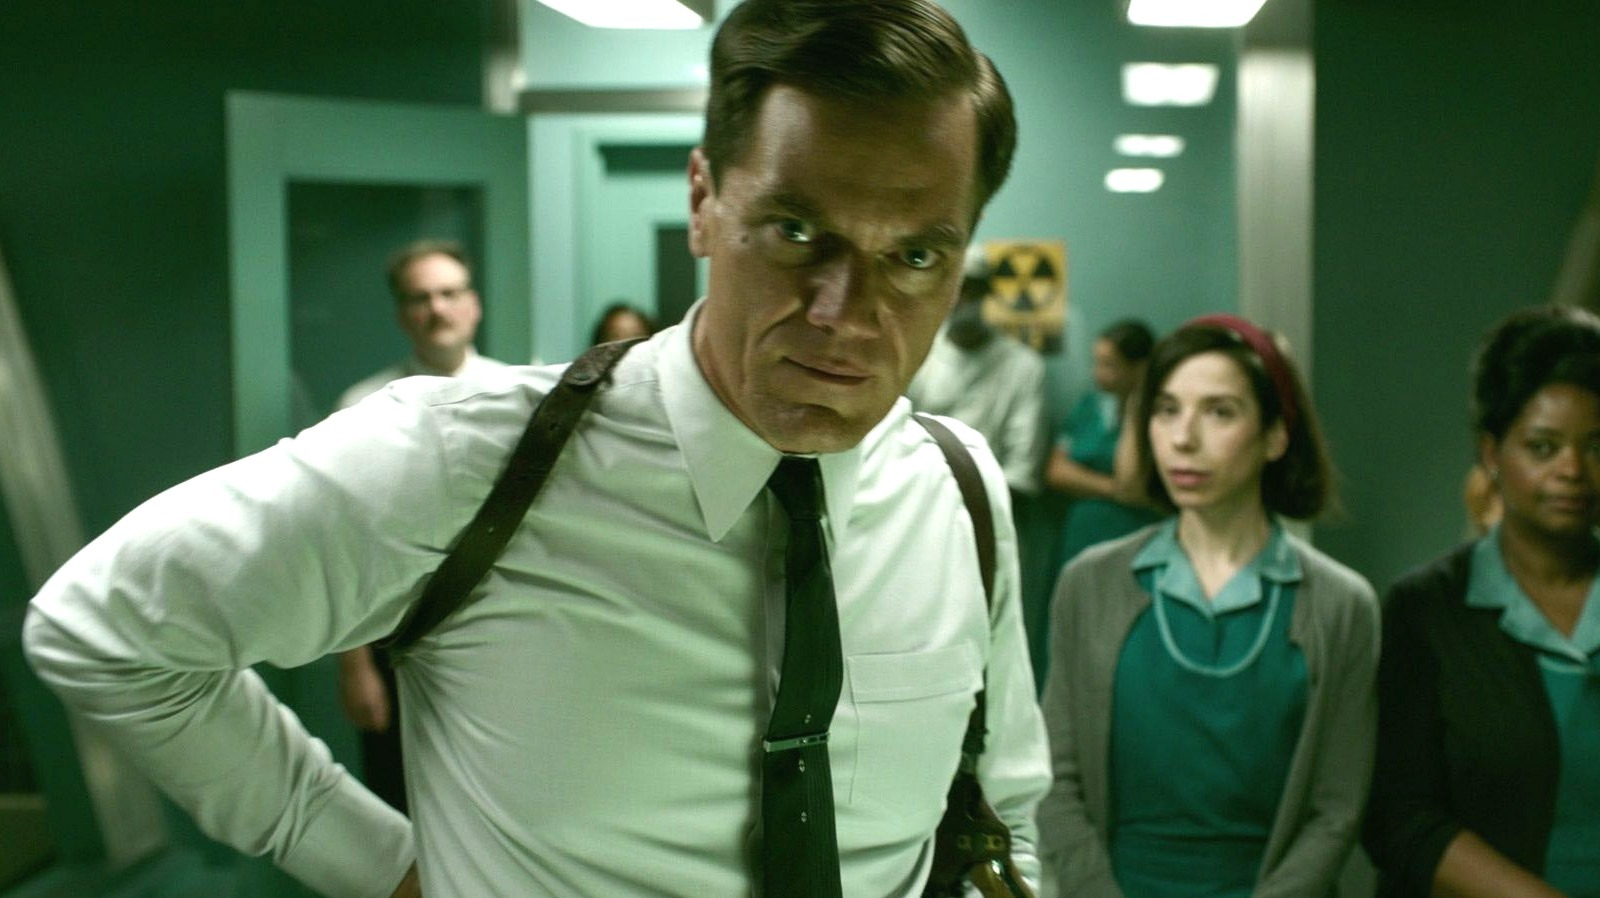What do you think is going on in this snapshot?
 In this image, the central figure is actor Michael Shannon, who is dressed in a white shirt, black suspenders, and a black tie. He stands with his hands on his hips, leaning forward slightly, and his gaze is directed to the side, reflecting a serious expression. Behind him, the scene is set in what appears to be a hospital or medical facility, characterized by a green color scheme and visible medical equipment. There are several other people in the background, including a woman dressed in a teal dress and a man wearing a white lab coat. 